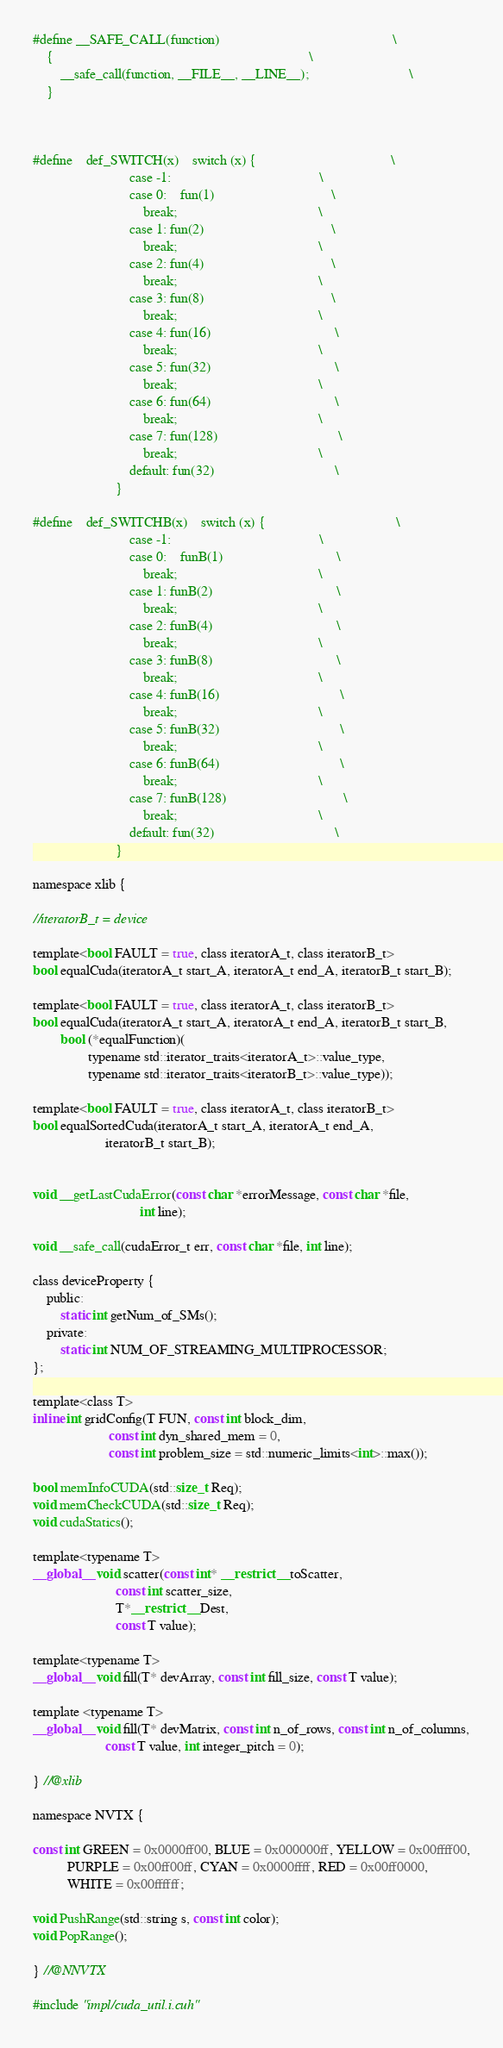<code> <loc_0><loc_0><loc_500><loc_500><_Cuda_>#define __SAFE_CALL(function)                                                  \
    {                                                                          \
        __safe_call(function, __FILE__, __LINE__);                             \
    }



#define    def_SWITCH(x)    switch (x) {                                       \
                            case -1:                                           \
                            case 0:    fun(1)                                  \
                                break;                                         \
                            case 1: fun(2)                                     \
                                break;                                         \
                            case 2: fun(4)                                     \
                                break;                                         \
                            case 3: fun(8)                                     \
                                break;                                         \
                            case 4: fun(16)                                    \
                                break;                                         \
                            case 5: fun(32)                                    \
                                break;                                         \
                            case 6: fun(64)                                    \
                                break;                                         \
                            case 7: fun(128)                                   \
                                break;                                         \
                            default: fun(32)                                   \
                        }

#define    def_SWITCHB(x)    switch (x) {                                      \
                            case -1:                                           \
                            case 0:    funB(1)                                 \
                                break;                                         \
                            case 1: funB(2)                                    \
                                break;                                         \
                            case 2: funB(4)                                    \
                                break;                                         \
                            case 3: funB(8)                                    \
                                break;                                         \
                            case 4: funB(16)                                   \
                                break;                                         \
                            case 5: funB(32)                                   \
                                break;                                         \
                            case 6: funB(64)                                   \
                                break;                                         \
                            case 7: funB(128)                                  \
                                break;                                         \
                            default: fun(32)                                   \
                        }

namespace xlib {

//iteratorB_t = device

template<bool FAULT = true, class iteratorA_t, class iteratorB_t>
bool equalCuda(iteratorA_t start_A, iteratorA_t end_A, iteratorB_t start_B);

template<bool FAULT = true, class iteratorA_t, class iteratorB_t>
bool equalCuda(iteratorA_t start_A, iteratorA_t end_A, iteratorB_t start_B,
        bool (*equalFunction)(
                typename std::iterator_traits<iteratorA_t>::value_type,
                typename std::iterator_traits<iteratorB_t>::value_type));

template<bool FAULT = true, class iteratorA_t, class iteratorB_t>
bool equalSortedCuda(iteratorA_t start_A, iteratorA_t end_A,
                     iteratorB_t start_B);


void __getLastCudaError(const char *errorMessage, const char *file,
                               int line);

void __safe_call(cudaError_t err, const char *file, int line);

class deviceProperty {
    public:
        static int getNum_of_SMs();
    private:
        static int NUM_OF_STREAMING_MULTIPROCESSOR;
};

template<class T>
inline int gridConfig(T FUN, const int block_dim,
                      const int dyn_shared_mem = 0,
                      const int problem_size = std::numeric_limits<int>::max());

bool memInfoCUDA(std::size_t Req);
void memCheckCUDA(std::size_t Req);
void cudaStatics();

template<typename T>
__global__ void scatter(const int* __restrict__ toScatter,
                        const int scatter_size,
                        T*__restrict__ Dest,
                        const T value);

template<typename T>
__global__ void fill(T* devArray, const int fill_size, const T value);

template <typename T>
__global__ void fill(T* devMatrix, const int n_of_rows, const int n_of_columns,
                     const T value, int integer_pitch = 0);

} //@xlib

namespace NVTX {

const int GREEN = 0x0000ff00, BLUE = 0x000000ff, YELLOW = 0x00ffff00,
          PURPLE = 0x00ff00ff, CYAN = 0x0000ffff, RED = 0x00ff0000,
          WHITE = 0x00ffffff;

void PushRange(std::string s, const int color);
void PopRange();

} //@NNVTX

#include "impl/cuda_util.i.cuh"
</code> 